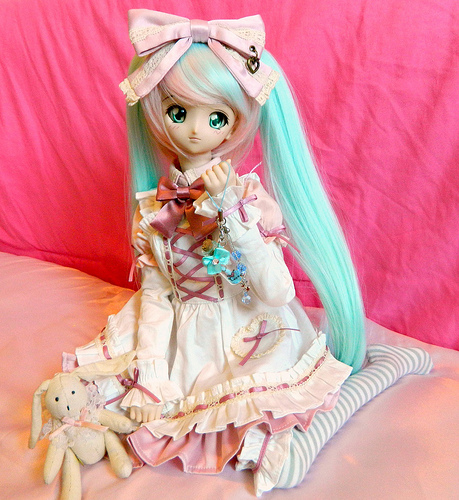<image>
Can you confirm if the bow is above the stuffed animal? Yes. The bow is positioned above the stuffed animal in the vertical space, higher up in the scene. 